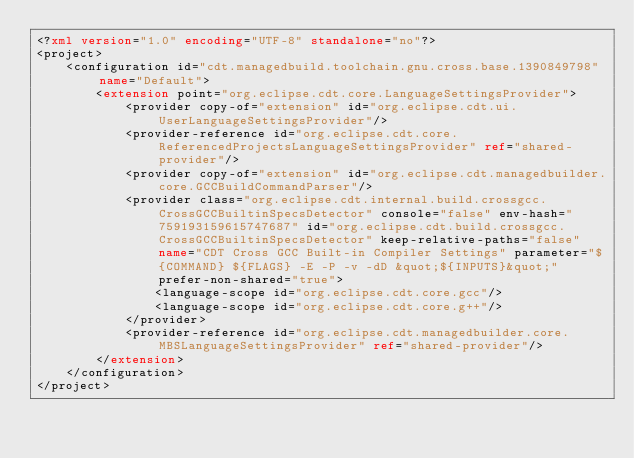<code> <loc_0><loc_0><loc_500><loc_500><_XML_><?xml version="1.0" encoding="UTF-8" standalone="no"?>
<project>
	<configuration id="cdt.managedbuild.toolchain.gnu.cross.base.1390849798" name="Default">
		<extension point="org.eclipse.cdt.core.LanguageSettingsProvider">
			<provider copy-of="extension" id="org.eclipse.cdt.ui.UserLanguageSettingsProvider"/>
			<provider-reference id="org.eclipse.cdt.core.ReferencedProjectsLanguageSettingsProvider" ref="shared-provider"/>
			<provider copy-of="extension" id="org.eclipse.cdt.managedbuilder.core.GCCBuildCommandParser"/>
			<provider class="org.eclipse.cdt.internal.build.crossgcc.CrossGCCBuiltinSpecsDetector" console="false" env-hash="759193159615747687" id="org.eclipse.cdt.build.crossgcc.CrossGCCBuiltinSpecsDetector" keep-relative-paths="false" name="CDT Cross GCC Built-in Compiler Settings" parameter="${COMMAND} ${FLAGS} -E -P -v -dD &quot;${INPUTS}&quot;" prefer-non-shared="true">
				<language-scope id="org.eclipse.cdt.core.gcc"/>
				<language-scope id="org.eclipse.cdt.core.g++"/>
			</provider>
			<provider-reference id="org.eclipse.cdt.managedbuilder.core.MBSLanguageSettingsProvider" ref="shared-provider"/>
		</extension>
	</configuration>
</project></code> 